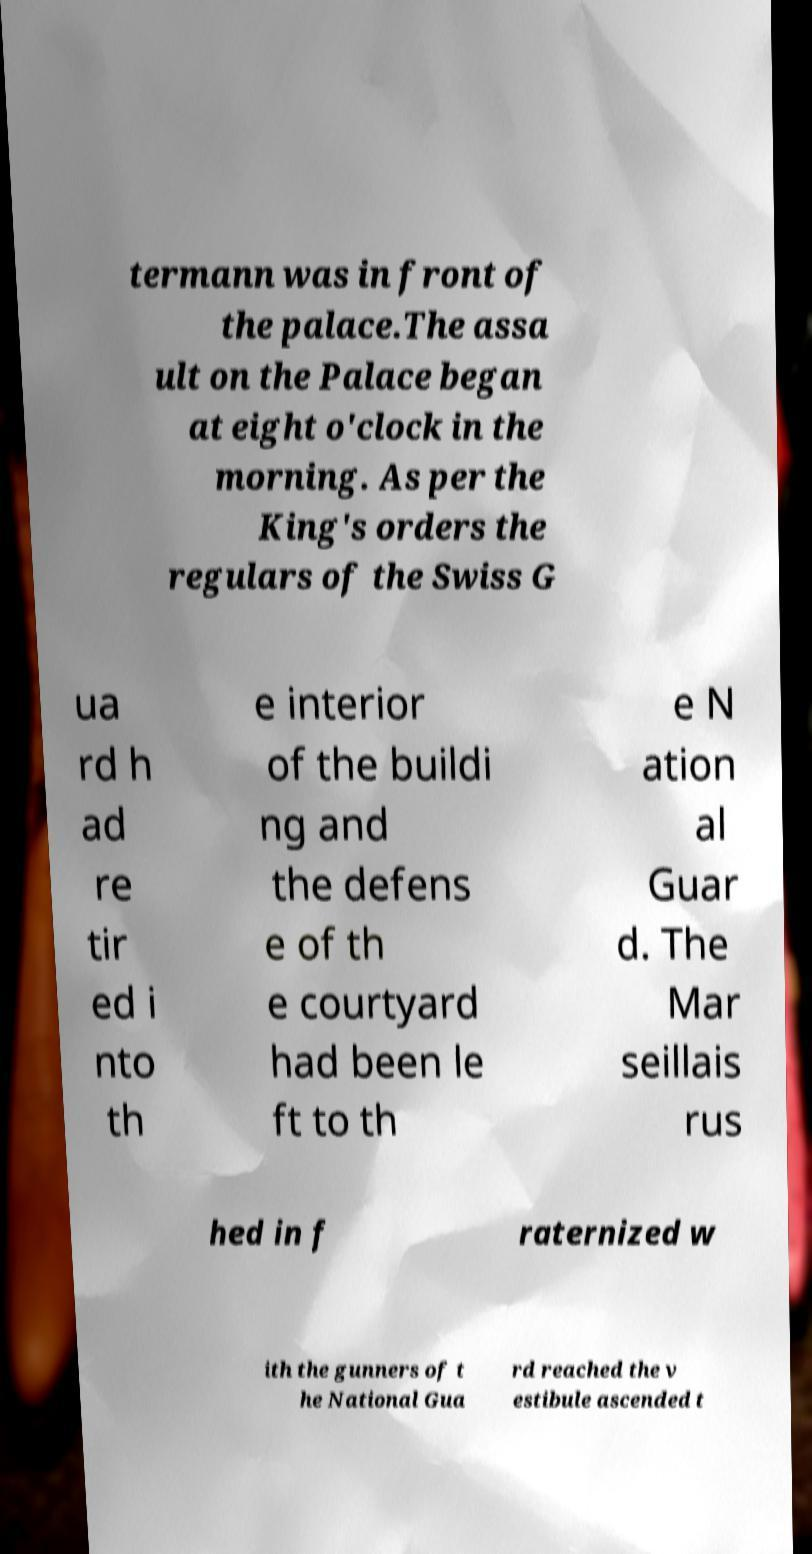For documentation purposes, I need the text within this image transcribed. Could you provide that? termann was in front of the palace.The assa ult on the Palace began at eight o'clock in the morning. As per the King's orders the regulars of the Swiss G ua rd h ad re tir ed i nto th e interior of the buildi ng and the defens e of th e courtyard had been le ft to th e N ation al Guar d. The Mar seillais rus hed in f raternized w ith the gunners of t he National Gua rd reached the v estibule ascended t 